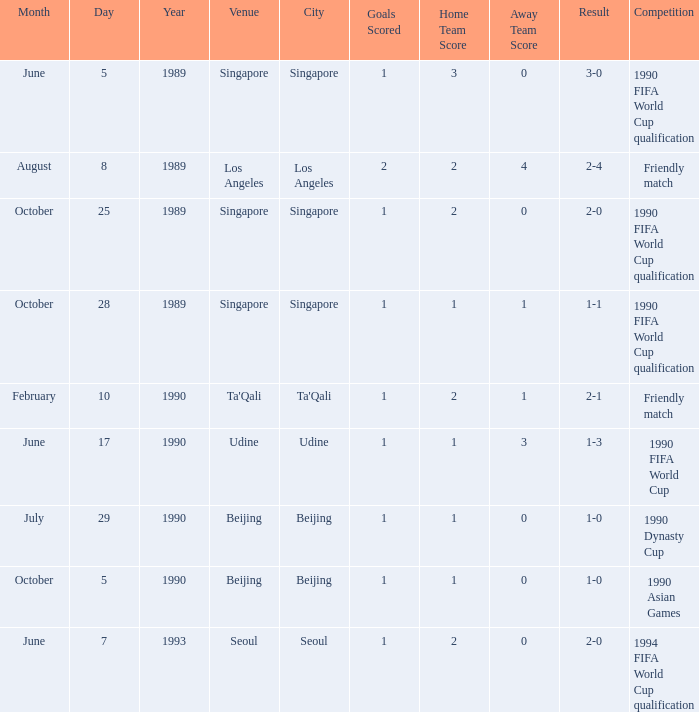What is the venue of the 1990 Asian games? Beijing. 